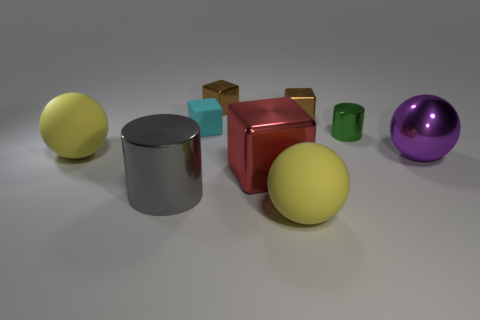Subtract all shiny cubes. How many cubes are left? 1 Subtract all red cubes. How many yellow balls are left? 2 Subtract all cyan blocks. How many blocks are left? 3 Add 1 tiny cylinders. How many objects exist? 10 Subtract all blue blocks. Subtract all red spheres. How many blocks are left? 4 Add 9 red metallic blocks. How many red metallic blocks are left? 10 Add 6 brown blocks. How many brown blocks exist? 8 Subtract 1 green cylinders. How many objects are left? 8 Subtract all balls. How many objects are left? 6 Subtract all tiny cylinders. Subtract all big shiny objects. How many objects are left? 5 